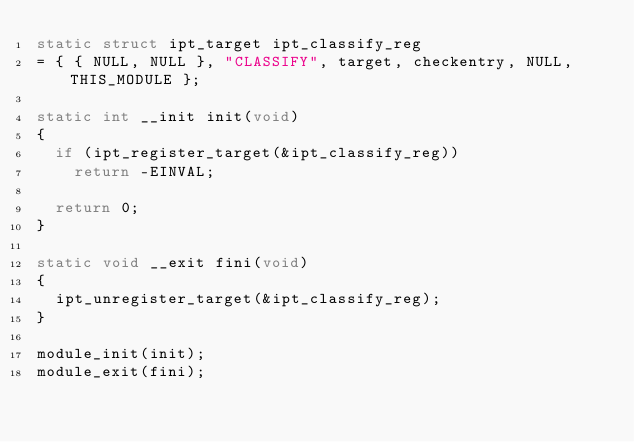<code> <loc_0><loc_0><loc_500><loc_500><_C_>static struct ipt_target ipt_classify_reg
= { { NULL, NULL }, "CLASSIFY", target, checkentry, NULL, THIS_MODULE };

static int __init init(void)
{
	if (ipt_register_target(&ipt_classify_reg))
		return -EINVAL;

	return 0;
}

static void __exit fini(void)
{
	ipt_unregister_target(&ipt_classify_reg);
}

module_init(init);
module_exit(fini);
</code> 